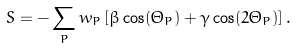<formula> <loc_0><loc_0><loc_500><loc_500>S = - \sum _ { P } w _ { P } \left [ \beta \cos ( \Theta _ { P } ) + \gamma \cos ( 2 \Theta _ { P } ) \right ] .</formula> 